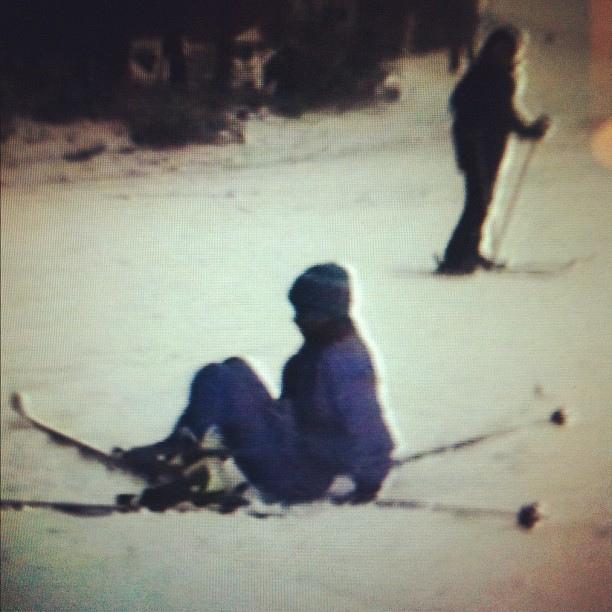How many people are there?
Give a very brief answer. 2. 